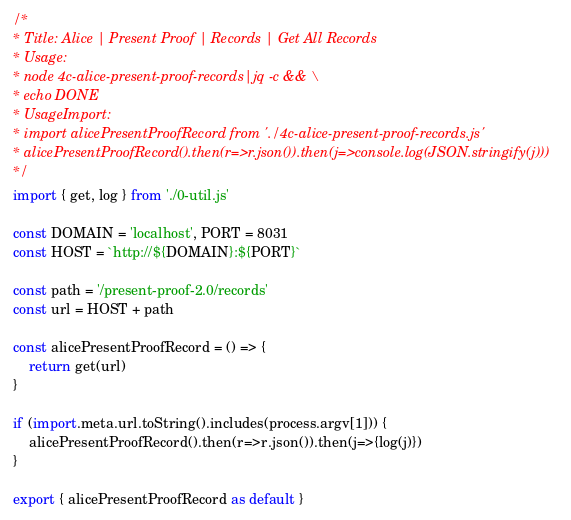<code> <loc_0><loc_0><loc_500><loc_500><_JavaScript_>/*
* Title: Alice | Present Proof | Records | Get All Records
* Usage:
* node 4c-alice-present-proof-records|jq -c && \
* echo DONE
* UsageImport:
* import alicePresentProofRecord from './4c-alice-present-proof-records.js'
* alicePresentProofRecord().then(r=>r.json()).then(j=>console.log(JSON.stringify(j)))
*/
import { get, log } from './0-util.js'

const DOMAIN = 'localhost', PORT = 8031
const HOST = `http://${DOMAIN}:${PORT}`

const path = '/present-proof-2.0/records'
const url = HOST + path

const alicePresentProofRecord = () => {
	return get(url)
}

if (import.meta.url.toString().includes(process.argv[1])) {
	alicePresentProofRecord().then(r=>r.json()).then(j=>{log(j)})
}

export { alicePresentProofRecord as default }
</code> 